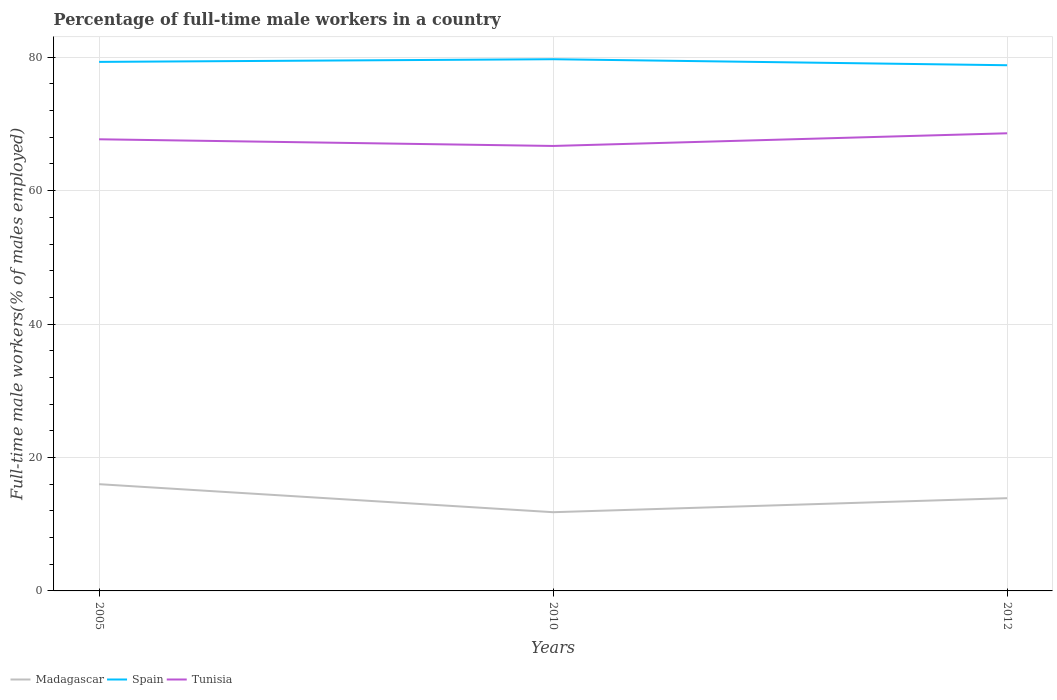Does the line corresponding to Spain intersect with the line corresponding to Tunisia?
Your response must be concise. No. Across all years, what is the maximum percentage of full-time male workers in Spain?
Provide a short and direct response. 78.8. In which year was the percentage of full-time male workers in Madagascar maximum?
Your response must be concise. 2010. What is the total percentage of full-time male workers in Spain in the graph?
Your answer should be very brief. 0.9. What is the difference between the highest and the second highest percentage of full-time male workers in Madagascar?
Provide a short and direct response. 4.2. What is the difference between the highest and the lowest percentage of full-time male workers in Spain?
Offer a terse response. 2. Is the percentage of full-time male workers in Madagascar strictly greater than the percentage of full-time male workers in Spain over the years?
Your response must be concise. Yes. How many years are there in the graph?
Offer a terse response. 3. Are the values on the major ticks of Y-axis written in scientific E-notation?
Your answer should be compact. No. Does the graph contain any zero values?
Your answer should be compact. No. Does the graph contain grids?
Offer a very short reply. Yes. Where does the legend appear in the graph?
Keep it short and to the point. Bottom left. How many legend labels are there?
Your response must be concise. 3. How are the legend labels stacked?
Provide a short and direct response. Horizontal. What is the title of the graph?
Make the answer very short. Percentage of full-time male workers in a country. Does "Latin America(developing only)" appear as one of the legend labels in the graph?
Ensure brevity in your answer.  No. What is the label or title of the Y-axis?
Offer a terse response. Full-time male workers(% of males employed). What is the Full-time male workers(% of males employed) of Spain in 2005?
Offer a very short reply. 79.3. What is the Full-time male workers(% of males employed) of Tunisia in 2005?
Provide a short and direct response. 67.7. What is the Full-time male workers(% of males employed) of Madagascar in 2010?
Your response must be concise. 11.8. What is the Full-time male workers(% of males employed) of Spain in 2010?
Ensure brevity in your answer.  79.7. What is the Full-time male workers(% of males employed) of Tunisia in 2010?
Your answer should be compact. 66.7. What is the Full-time male workers(% of males employed) of Madagascar in 2012?
Provide a short and direct response. 13.9. What is the Full-time male workers(% of males employed) in Spain in 2012?
Offer a terse response. 78.8. What is the Full-time male workers(% of males employed) in Tunisia in 2012?
Make the answer very short. 68.6. Across all years, what is the maximum Full-time male workers(% of males employed) in Madagascar?
Provide a short and direct response. 16. Across all years, what is the maximum Full-time male workers(% of males employed) of Spain?
Your answer should be compact. 79.7. Across all years, what is the maximum Full-time male workers(% of males employed) in Tunisia?
Your response must be concise. 68.6. Across all years, what is the minimum Full-time male workers(% of males employed) in Madagascar?
Provide a short and direct response. 11.8. Across all years, what is the minimum Full-time male workers(% of males employed) in Spain?
Make the answer very short. 78.8. Across all years, what is the minimum Full-time male workers(% of males employed) in Tunisia?
Give a very brief answer. 66.7. What is the total Full-time male workers(% of males employed) of Madagascar in the graph?
Give a very brief answer. 41.7. What is the total Full-time male workers(% of males employed) of Spain in the graph?
Offer a very short reply. 237.8. What is the total Full-time male workers(% of males employed) of Tunisia in the graph?
Ensure brevity in your answer.  203. What is the difference between the Full-time male workers(% of males employed) of Spain in 2005 and that in 2010?
Your response must be concise. -0.4. What is the difference between the Full-time male workers(% of males employed) of Tunisia in 2005 and that in 2010?
Your response must be concise. 1. What is the difference between the Full-time male workers(% of males employed) of Madagascar in 2005 and that in 2012?
Provide a succinct answer. 2.1. What is the difference between the Full-time male workers(% of males employed) of Tunisia in 2005 and that in 2012?
Ensure brevity in your answer.  -0.9. What is the difference between the Full-time male workers(% of males employed) of Madagascar in 2010 and that in 2012?
Your answer should be compact. -2.1. What is the difference between the Full-time male workers(% of males employed) of Spain in 2010 and that in 2012?
Your answer should be compact. 0.9. What is the difference between the Full-time male workers(% of males employed) of Madagascar in 2005 and the Full-time male workers(% of males employed) of Spain in 2010?
Your answer should be very brief. -63.7. What is the difference between the Full-time male workers(% of males employed) in Madagascar in 2005 and the Full-time male workers(% of males employed) in Tunisia in 2010?
Ensure brevity in your answer.  -50.7. What is the difference between the Full-time male workers(% of males employed) of Spain in 2005 and the Full-time male workers(% of males employed) of Tunisia in 2010?
Your answer should be very brief. 12.6. What is the difference between the Full-time male workers(% of males employed) of Madagascar in 2005 and the Full-time male workers(% of males employed) of Spain in 2012?
Your response must be concise. -62.8. What is the difference between the Full-time male workers(% of males employed) in Madagascar in 2005 and the Full-time male workers(% of males employed) in Tunisia in 2012?
Your answer should be very brief. -52.6. What is the difference between the Full-time male workers(% of males employed) in Madagascar in 2010 and the Full-time male workers(% of males employed) in Spain in 2012?
Your answer should be very brief. -67. What is the difference between the Full-time male workers(% of males employed) in Madagascar in 2010 and the Full-time male workers(% of males employed) in Tunisia in 2012?
Make the answer very short. -56.8. What is the average Full-time male workers(% of males employed) of Madagascar per year?
Offer a very short reply. 13.9. What is the average Full-time male workers(% of males employed) in Spain per year?
Offer a very short reply. 79.27. What is the average Full-time male workers(% of males employed) in Tunisia per year?
Make the answer very short. 67.67. In the year 2005, what is the difference between the Full-time male workers(% of males employed) of Madagascar and Full-time male workers(% of males employed) of Spain?
Your answer should be compact. -63.3. In the year 2005, what is the difference between the Full-time male workers(% of males employed) of Madagascar and Full-time male workers(% of males employed) of Tunisia?
Your answer should be very brief. -51.7. In the year 2005, what is the difference between the Full-time male workers(% of males employed) of Spain and Full-time male workers(% of males employed) of Tunisia?
Keep it short and to the point. 11.6. In the year 2010, what is the difference between the Full-time male workers(% of males employed) of Madagascar and Full-time male workers(% of males employed) of Spain?
Provide a short and direct response. -67.9. In the year 2010, what is the difference between the Full-time male workers(% of males employed) in Madagascar and Full-time male workers(% of males employed) in Tunisia?
Give a very brief answer. -54.9. In the year 2012, what is the difference between the Full-time male workers(% of males employed) of Madagascar and Full-time male workers(% of males employed) of Spain?
Your answer should be compact. -64.9. In the year 2012, what is the difference between the Full-time male workers(% of males employed) in Madagascar and Full-time male workers(% of males employed) in Tunisia?
Ensure brevity in your answer.  -54.7. What is the ratio of the Full-time male workers(% of males employed) of Madagascar in 2005 to that in 2010?
Offer a very short reply. 1.36. What is the ratio of the Full-time male workers(% of males employed) of Spain in 2005 to that in 2010?
Your answer should be very brief. 0.99. What is the ratio of the Full-time male workers(% of males employed) in Madagascar in 2005 to that in 2012?
Your response must be concise. 1.15. What is the ratio of the Full-time male workers(% of males employed) in Spain in 2005 to that in 2012?
Offer a terse response. 1.01. What is the ratio of the Full-time male workers(% of males employed) of Tunisia in 2005 to that in 2012?
Provide a succinct answer. 0.99. What is the ratio of the Full-time male workers(% of males employed) of Madagascar in 2010 to that in 2012?
Your answer should be very brief. 0.85. What is the ratio of the Full-time male workers(% of males employed) of Spain in 2010 to that in 2012?
Provide a short and direct response. 1.01. What is the ratio of the Full-time male workers(% of males employed) of Tunisia in 2010 to that in 2012?
Provide a short and direct response. 0.97. What is the difference between the highest and the second highest Full-time male workers(% of males employed) of Madagascar?
Offer a very short reply. 2.1. What is the difference between the highest and the second highest Full-time male workers(% of males employed) in Tunisia?
Provide a short and direct response. 0.9. What is the difference between the highest and the lowest Full-time male workers(% of males employed) in Tunisia?
Provide a short and direct response. 1.9. 